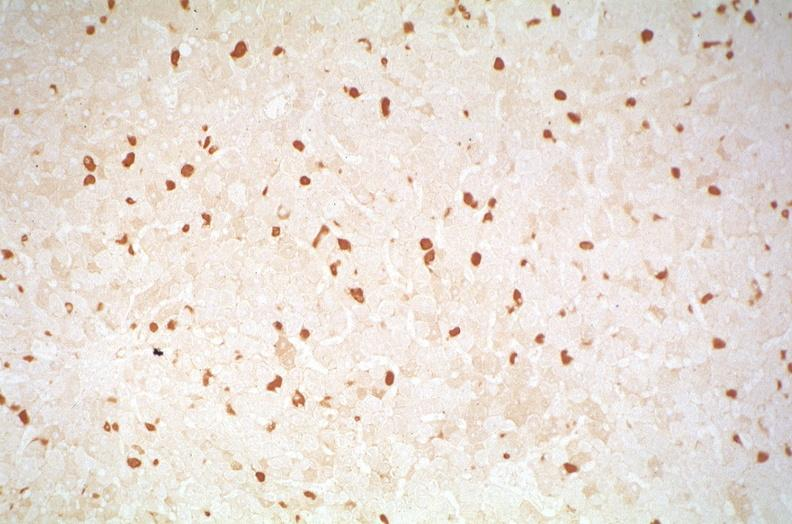does villous adenoma show hepatitis b virus, hepatocellular carcinoma?
Answer the question using a single word or phrase. No 